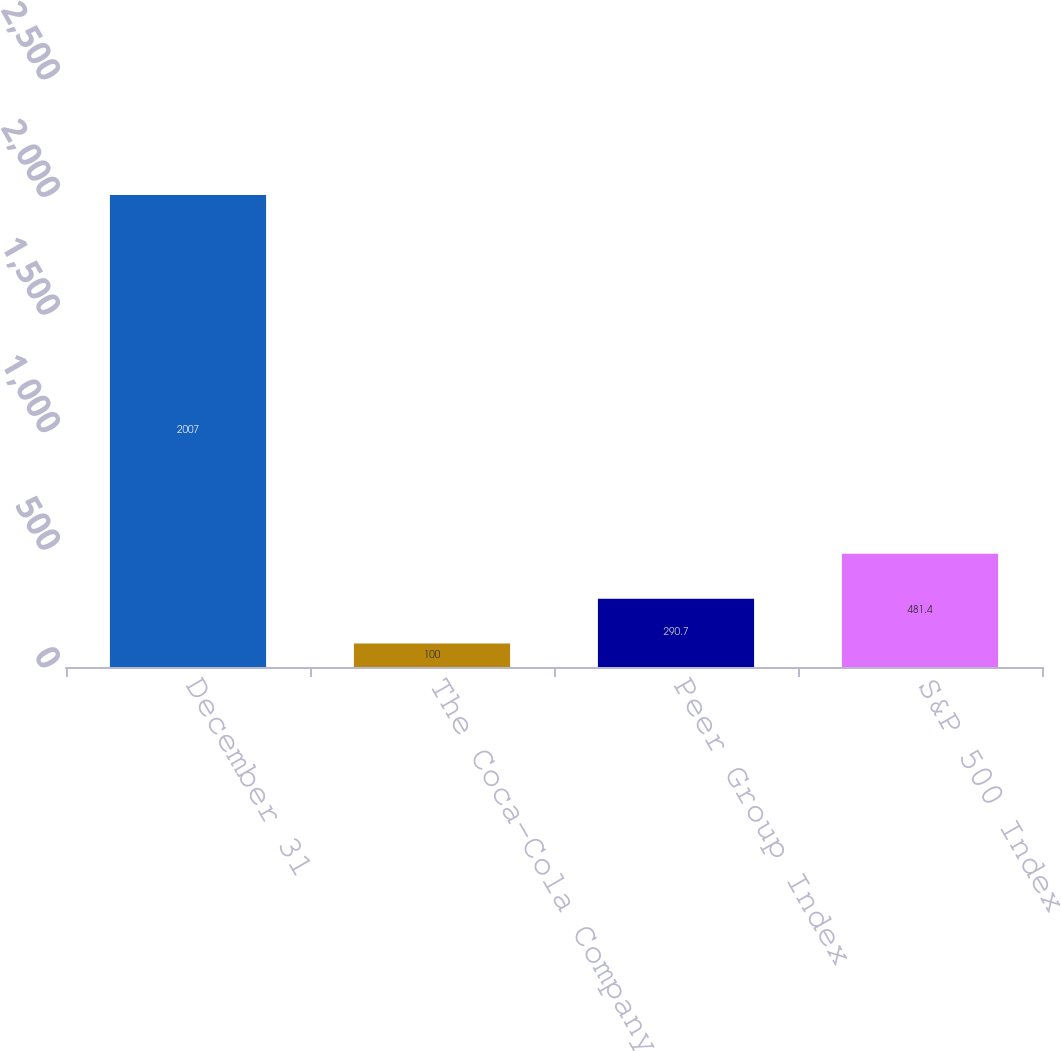Convert chart to OTSL. <chart><loc_0><loc_0><loc_500><loc_500><bar_chart><fcel>December 31<fcel>The Coca-Cola Company<fcel>Peer Group Index<fcel>S&P 500 Index<nl><fcel>2007<fcel>100<fcel>290.7<fcel>481.4<nl></chart> 